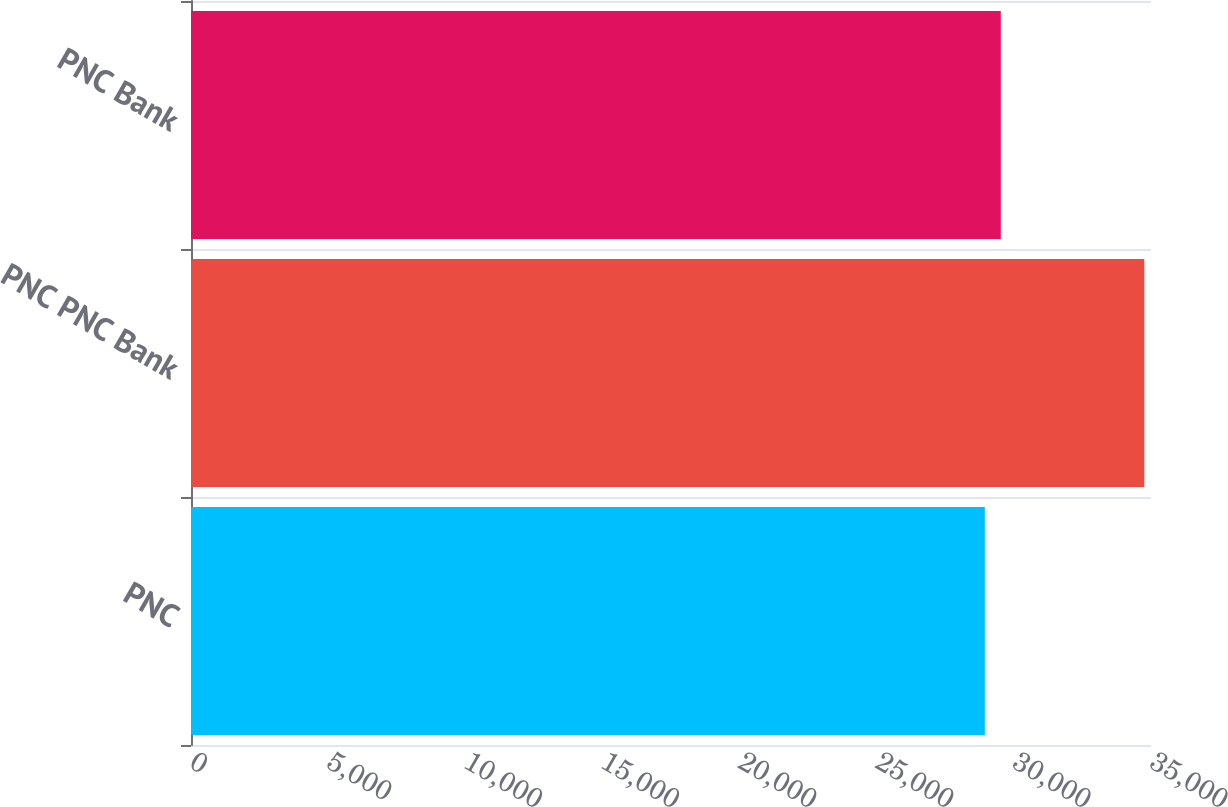<chart> <loc_0><loc_0><loc_500><loc_500><bar_chart><fcel>PNC<fcel>PNC PNC Bank<fcel>PNC Bank<nl><fcel>28942<fcel>34756<fcel>29523.4<nl></chart> 